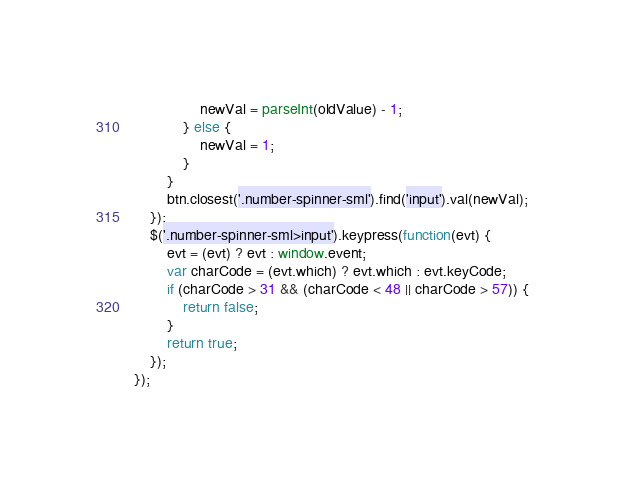Convert code to text. <code><loc_0><loc_0><loc_500><loc_500><_JavaScript_>                newVal = parseInt(oldValue) - 1;
            } else {
                newVal = 1;
            }
        }
        btn.closest('.number-spinner-sml').find('input').val(newVal);
    });
    $('.number-spinner-sml>input').keypress(function(evt) {
        evt = (evt) ? evt : window.event;
        var charCode = (evt.which) ? evt.which : evt.keyCode;
        if (charCode > 31 && (charCode < 48 || charCode > 57)) {
            return false;
        }
        return true;
    });
});
</code> 